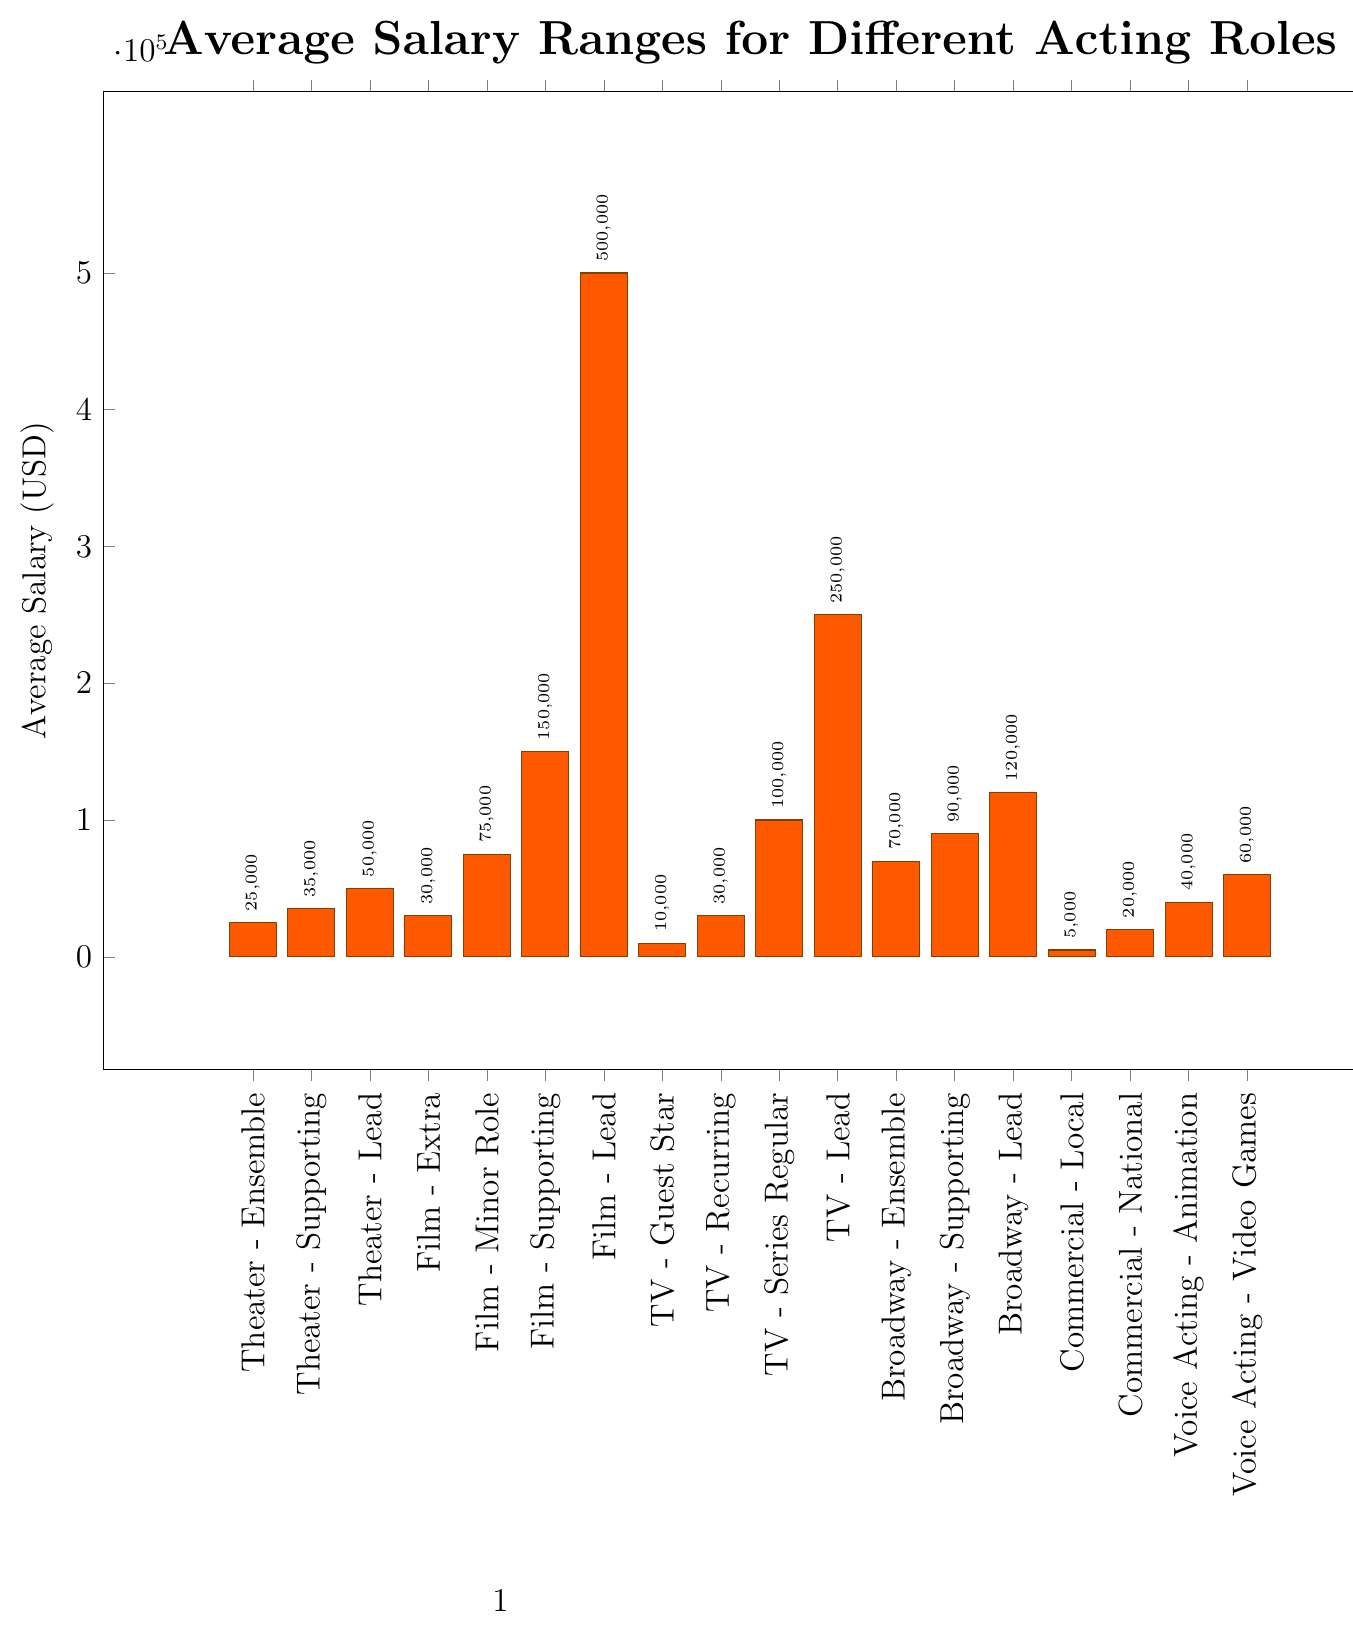What's the average salary for Theater - Ensemble and Theater - Supporting roles combined? To get the average salary for Theater - Ensemble and Theater - Supporting roles, first add their salaries (25000 + 35000) which equals 60000, then divide by the number of roles (which is 2), hence 60000/2 = 30000
Answer: 30000 Which acting role has the highest average salary? Among the various acting roles listed, the highest average salary is represented by the highest bar. The Film - Lead role has the highest average salary of 500000 USD
Answer: Film - Lead Compare the average salaries of Film - Supporting and TV - Lead roles. Which one is higher and by how much? Film - Supporting has an average salary of 150000 USD, and TV - Lead has an average salary of 250000 USD. Subtract 150000 from 250000 to find the difference, which is 100000 USD. Therefore, TV - Lead is higher by 100000 USD
Answer: TV - Lead, 100000 USD What's the total combined average salary for all Theater roles? There are three Theater roles: Ensemble (25000 USD), Supporting (35000 USD), and Lead (50000 USD). Adding these together yields 25000 + 35000 + 50000, which equals 110000 USD
Answer: 110000 What's the difference in the average salary between Commercial - Local and Commercial - National roles? Commercial - Local has an average salary of 5000 USD and Commercial - National has an average salary of 20000 USD. Subtract 5000 from 20000 to get the difference, which is 15000 USD
Answer: 15000 Identify the role with the lowest average salary and state its amount. The lowest average salary is represented by the shortest bar in the chart. That role is Commercial - Local with an average salary of 5000 USD
Answer: Commercial - Local, 5000 USD How does the average salary for Broadway - Lead compare to that of Theater - Lead? The average salary for Broadway - Lead is 120000 USD, while for Theater - Lead it is 50000 USD. Broadway - Lead earns 120000 - 50000 = 70000 USD more than Theater - Lead
Answer: Broadway - Lead, 70000 USD more What's the average salary for all roles in Film? The Film roles and their salaries are: Extra (30000 USD), Minor Role (75000 USD), Supporting (150000 USD), and Lead (500000 USD). Summing these gives 30000 + 75000 + 150000 + 500000 = 755000. There are 4 roles, so the average is 755000 / 4 = 188750
Answer: 188750 What's the median average salary of all acting roles listed in the chart? First, list the salaries in ascending order: 5000, 10000, 20000, 25000, 30000, 30000, 35000, 40000, 50000, 60000, 70000, 75000, 90000, 100000, 120000, 150000, 250000, 500000. There are 18 roles, so the median is the average of the 9th and 10th values in this list: (50000 + 60000) / 2 = 55000
Answer: 55000 Which has a higher average salary: Voice Acting - Animation or TV - Recurring? Voice Acting - Animation has an average salary of 40000 USD, whereas TV - Recurring has an average salary of 30000 USD. Therefore, Voice Acting - Animation has a higher average salary by 40000 - 30000 = 10000 USD
Answer: Voice Acting - Animation, 10000 USD higher 